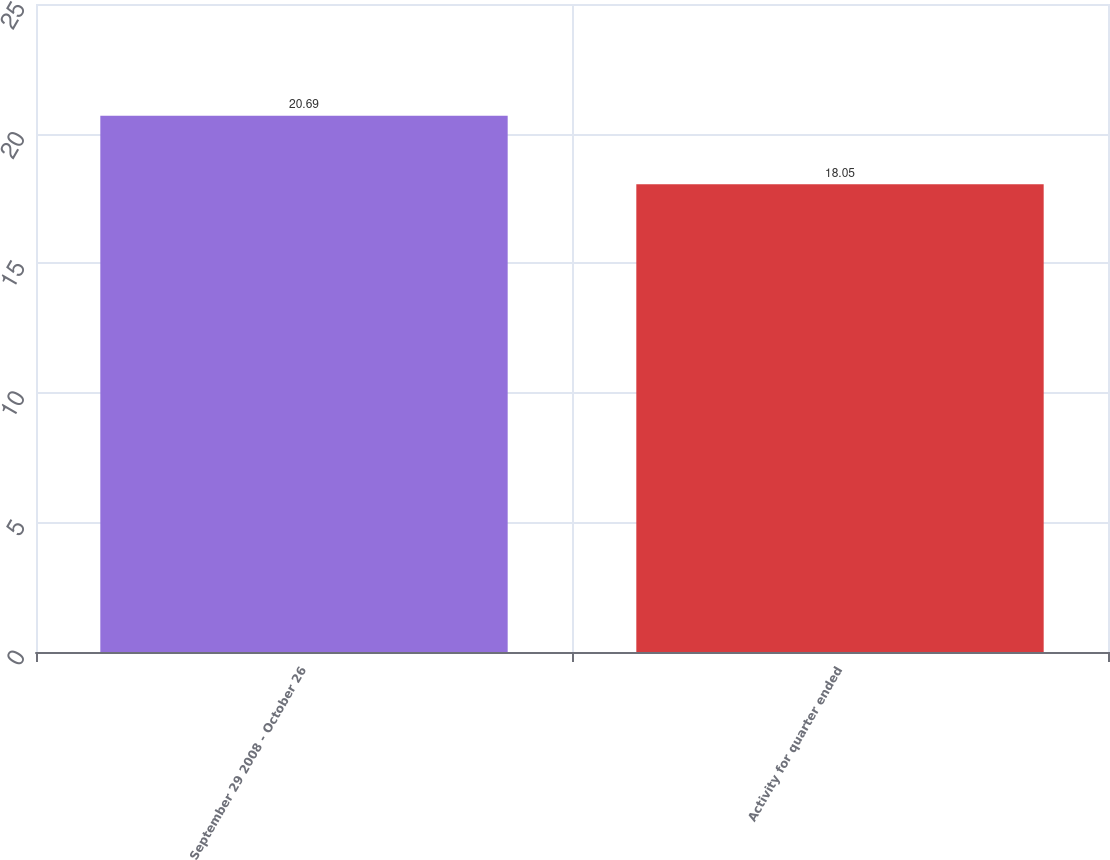Convert chart. <chart><loc_0><loc_0><loc_500><loc_500><bar_chart><fcel>September 29 2008 - October 26<fcel>Activity for quarter ended<nl><fcel>20.69<fcel>18.05<nl></chart> 